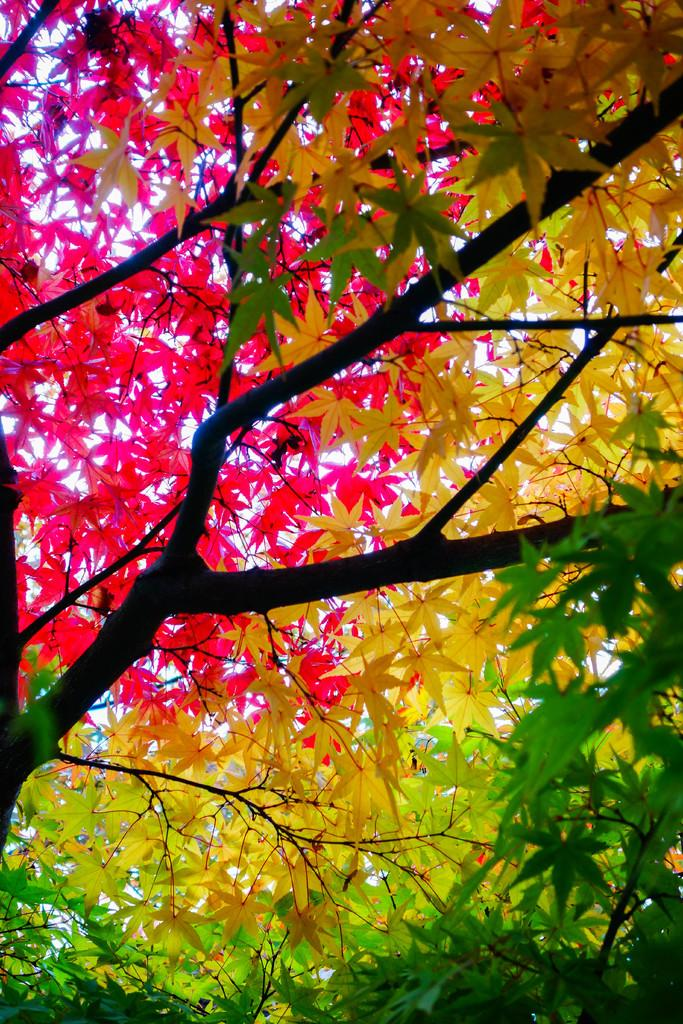What type of vegetation is present in the image? The image contains trees. What can be observed about the leaves on the trees? The leaves on the trees have different colors. Can you describe the colors of the leaves in the image? There are green, yellow, and pink leaves in the image. What type of blade is being sold in the shop in the image? There is no shop or blade present in the image; it features trees with leaves of different colors. 